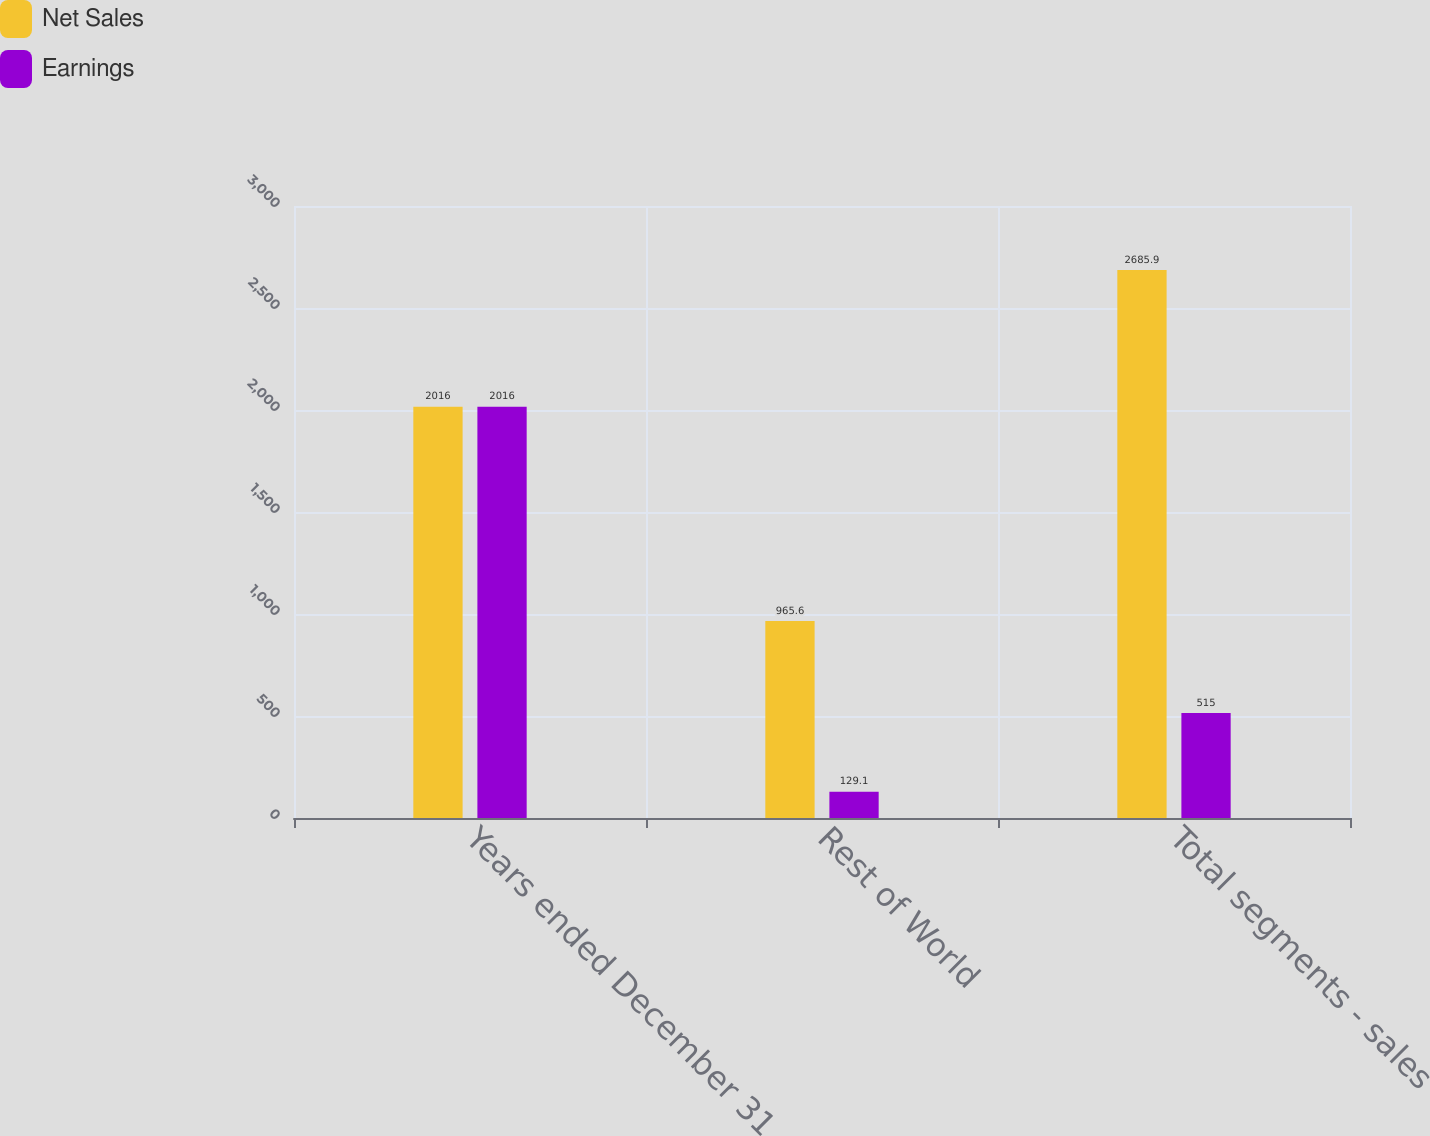Convert chart to OTSL. <chart><loc_0><loc_0><loc_500><loc_500><stacked_bar_chart><ecel><fcel>Years ended December 31<fcel>Rest of World<fcel>Total segments - sales<nl><fcel>Net Sales<fcel>2016<fcel>965.6<fcel>2685.9<nl><fcel>Earnings<fcel>2016<fcel>129.1<fcel>515<nl></chart> 